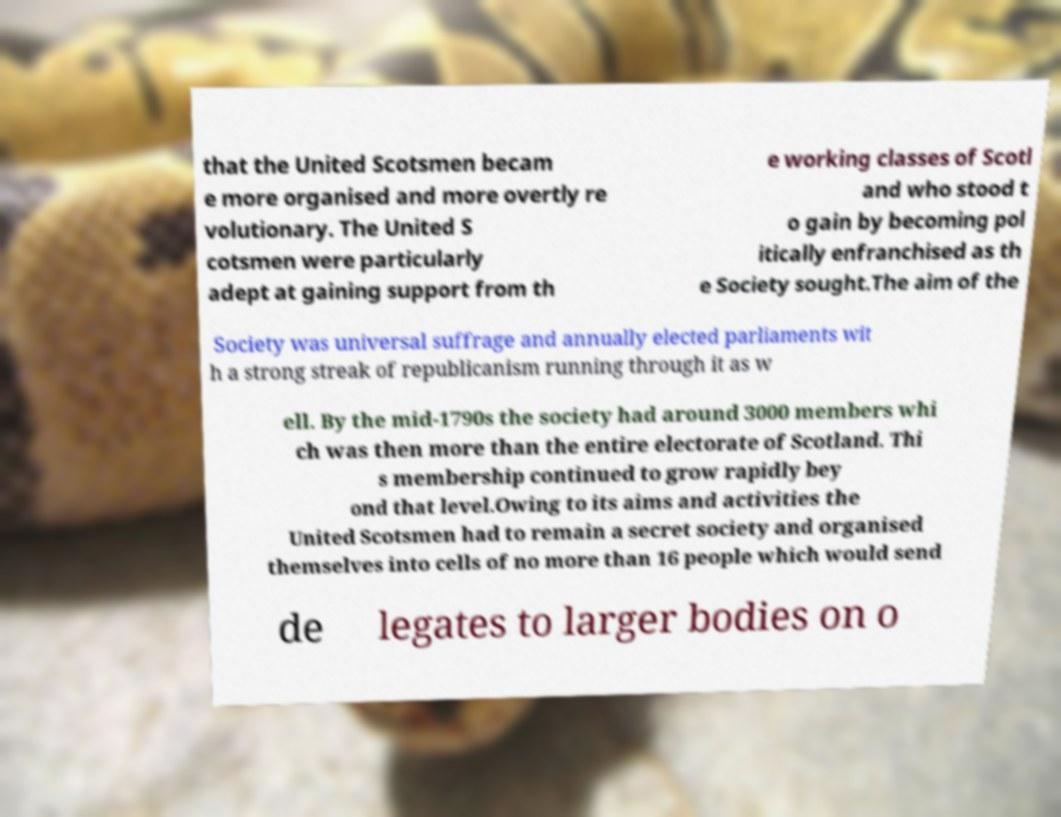Could you extract and type out the text from this image? that the United Scotsmen becam e more organised and more overtly re volutionary. The United S cotsmen were particularly adept at gaining support from th e working classes of Scotl and who stood t o gain by becoming pol itically enfranchised as th e Society sought.The aim of the Society was universal suffrage and annually elected parliaments wit h a strong streak of republicanism running through it as w ell. By the mid-1790s the society had around 3000 members whi ch was then more than the entire electorate of Scotland. Thi s membership continued to grow rapidly bey ond that level.Owing to its aims and activities the United Scotsmen had to remain a secret society and organised themselves into cells of no more than 16 people which would send de legates to larger bodies on o 